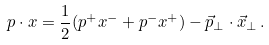Convert formula to latex. <formula><loc_0><loc_0><loc_500><loc_500>p \cdot x = \frac { 1 } { 2 } ( p ^ { + } x ^ { - } + p ^ { - } x ^ { + } ) - \vec { p } _ { \perp } \cdot \vec { x } _ { \perp } \, .</formula> 